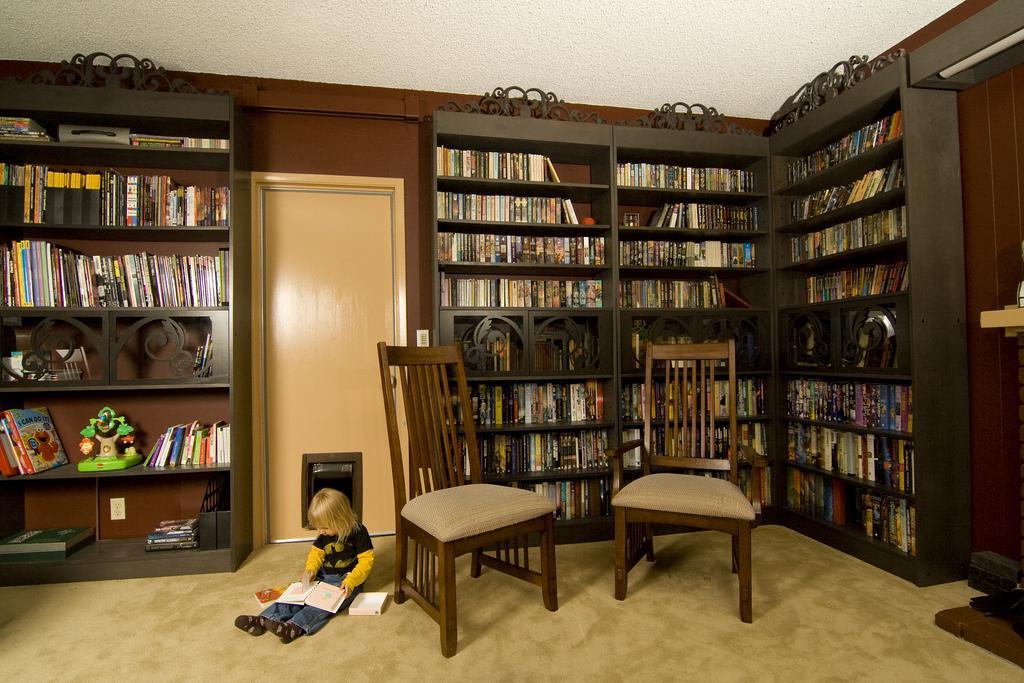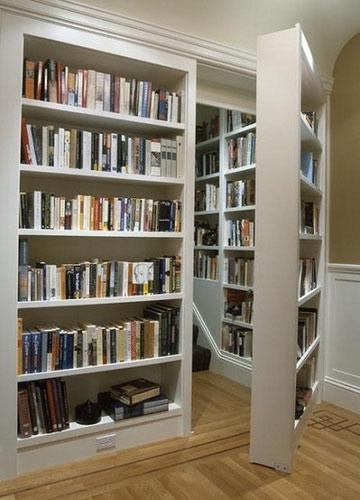The first image is the image on the left, the second image is the image on the right. For the images shown, is this caption "There is at least one chair near the bookshelves." true? Answer yes or no. Yes. 